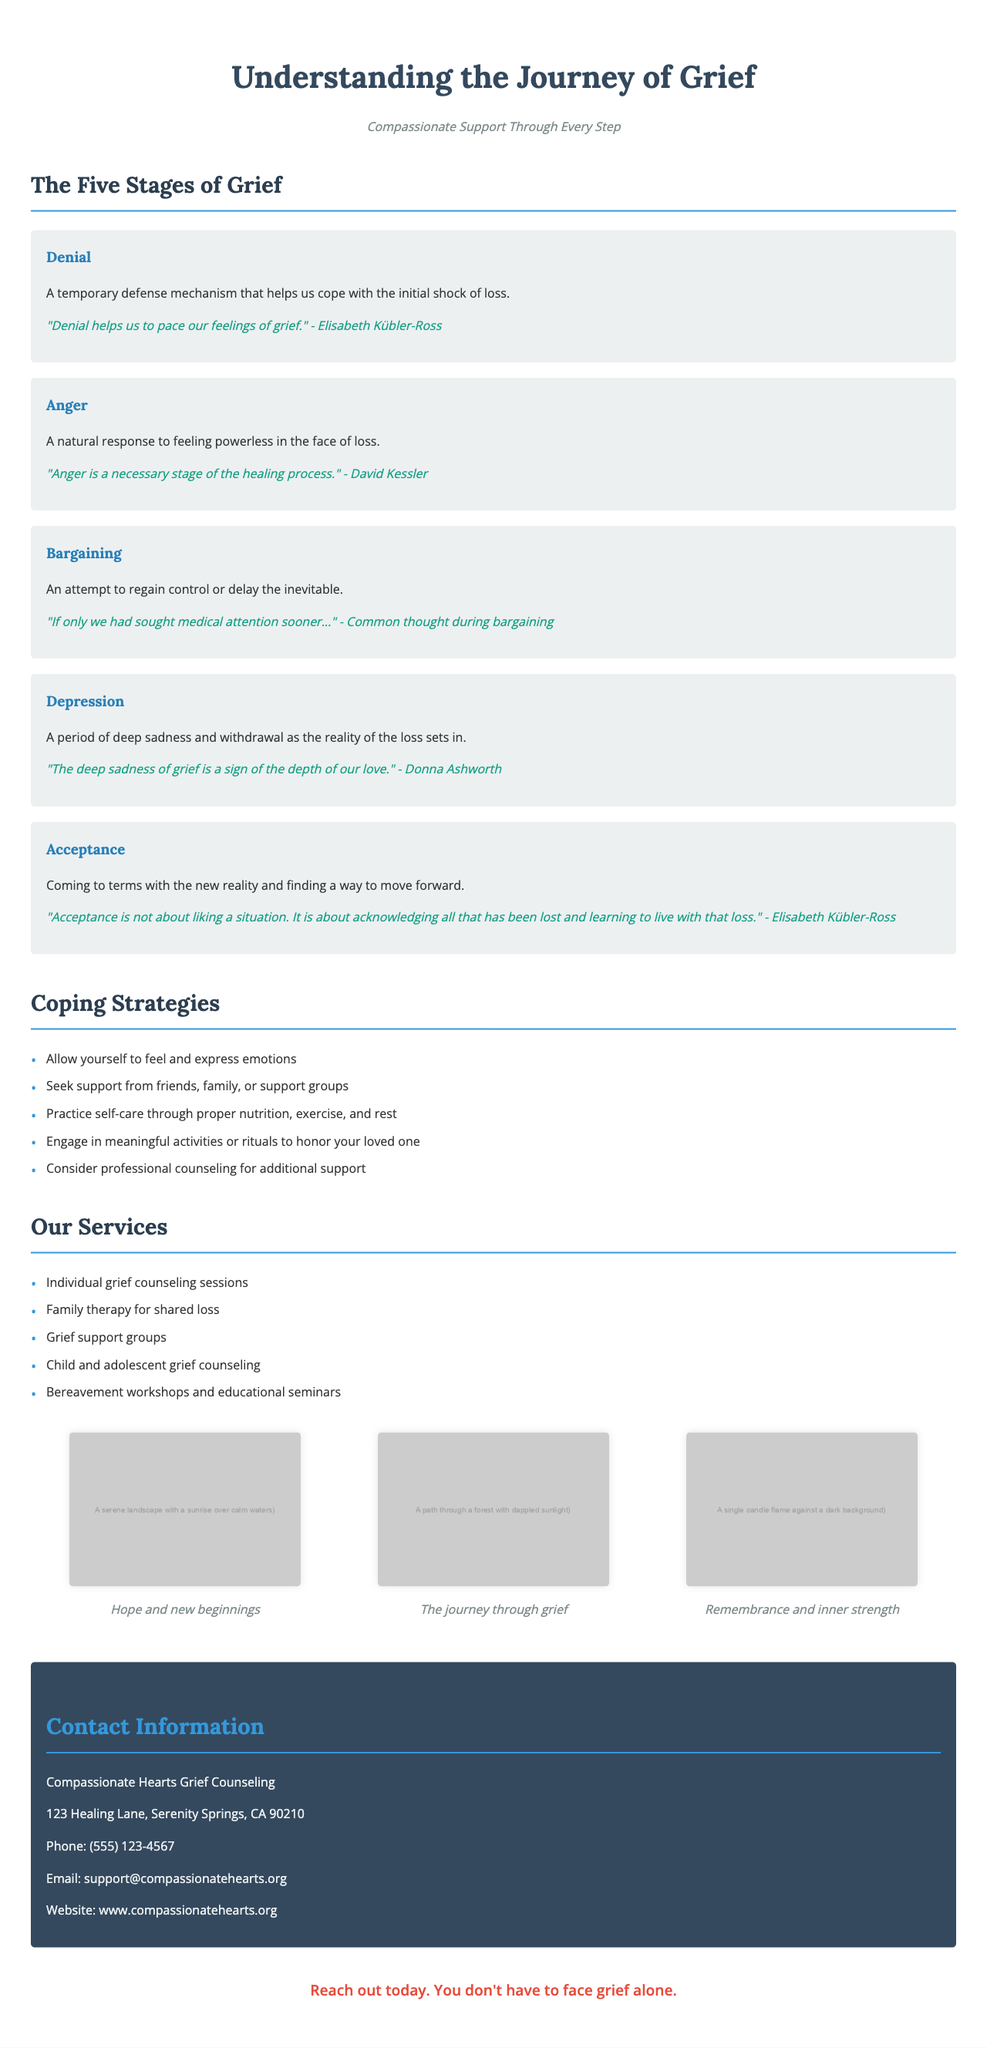What is the title of the brochure? The title is stated at the top of the document.
Answer: Understanding the Journey of Grief What stage comes after denial? The stages of grief are listed in order, which can be referenced in the document.
Answer: Anger What is one coping strategy suggested in the brochure? The brochure provides a list of coping strategies for those grieving.
Answer: Seek support from friends, family, or support groups How many stages of grief are detailed in the brochure? The document outlines a specific number of stages of grief.
Answer: Five Who is the author of the quote about acceptance? The quote about acceptance is attributed to a well-known figure in the field of grief counseling mentioned in the document.
Answer: Elisabeth Kübler-Ross What imagery symbolizes hope and new beginnings? The brochure includes descriptions of images and their symbolism.
Answer: A serene landscape with a sunrise over calm waters What type of therapy is offered for families experiencing shared loss? The document lists various services provided, including specific types of therapy.
Answer: Family therapy for shared loss What is the contact phone number for Compassionate Hearts Grief Counseling? The contact information section details how to reach the organization.
Answer: (555) 123-4567 What is the tagline of the brochure? The tagline is prominently displayed underneath the title, summarizing the brochure’s intent.
Answer: Compassionate Support Through Every Step 